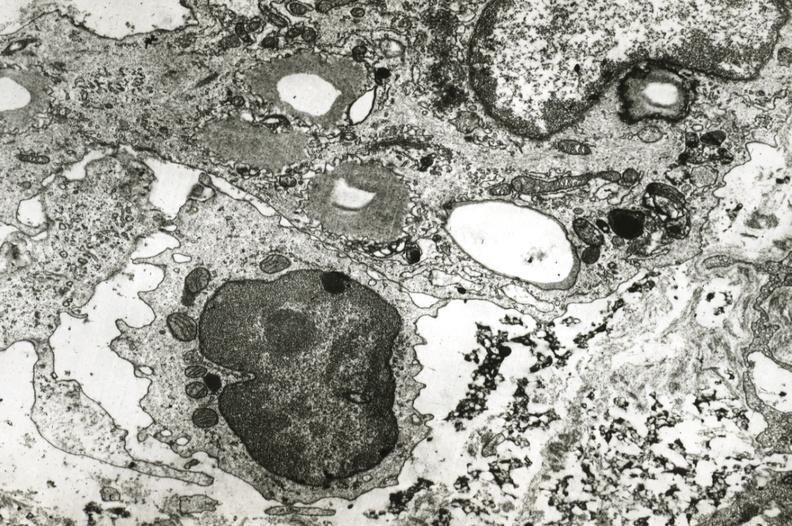what is present?
Answer the question using a single word or phrase. Vasculature 